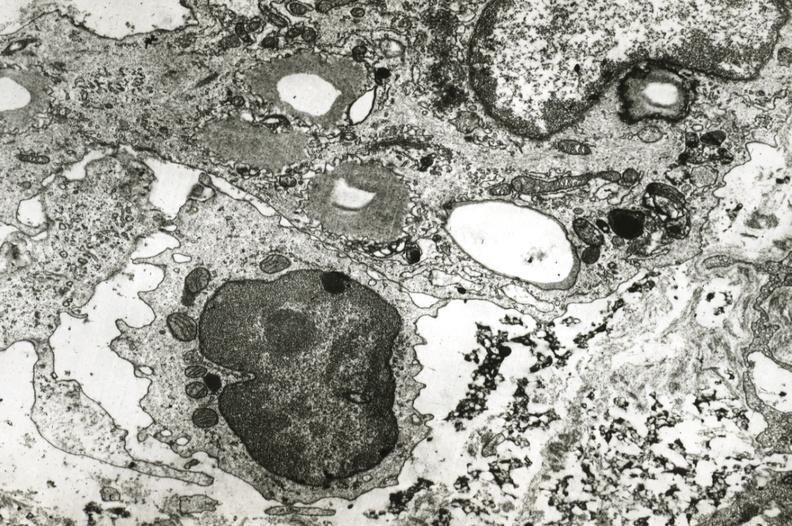what is present?
Answer the question using a single word or phrase. Vasculature 